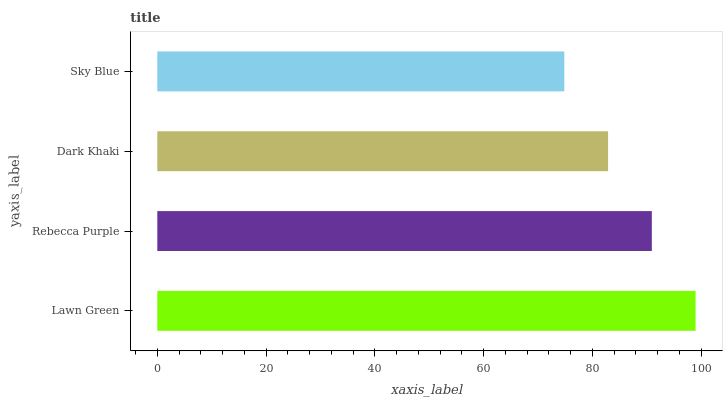Is Sky Blue the minimum?
Answer yes or no. Yes. Is Lawn Green the maximum?
Answer yes or no. Yes. Is Rebecca Purple the minimum?
Answer yes or no. No. Is Rebecca Purple the maximum?
Answer yes or no. No. Is Lawn Green greater than Rebecca Purple?
Answer yes or no. Yes. Is Rebecca Purple less than Lawn Green?
Answer yes or no. Yes. Is Rebecca Purple greater than Lawn Green?
Answer yes or no. No. Is Lawn Green less than Rebecca Purple?
Answer yes or no. No. Is Rebecca Purple the high median?
Answer yes or no. Yes. Is Dark Khaki the low median?
Answer yes or no. Yes. Is Dark Khaki the high median?
Answer yes or no. No. Is Rebecca Purple the low median?
Answer yes or no. No. 